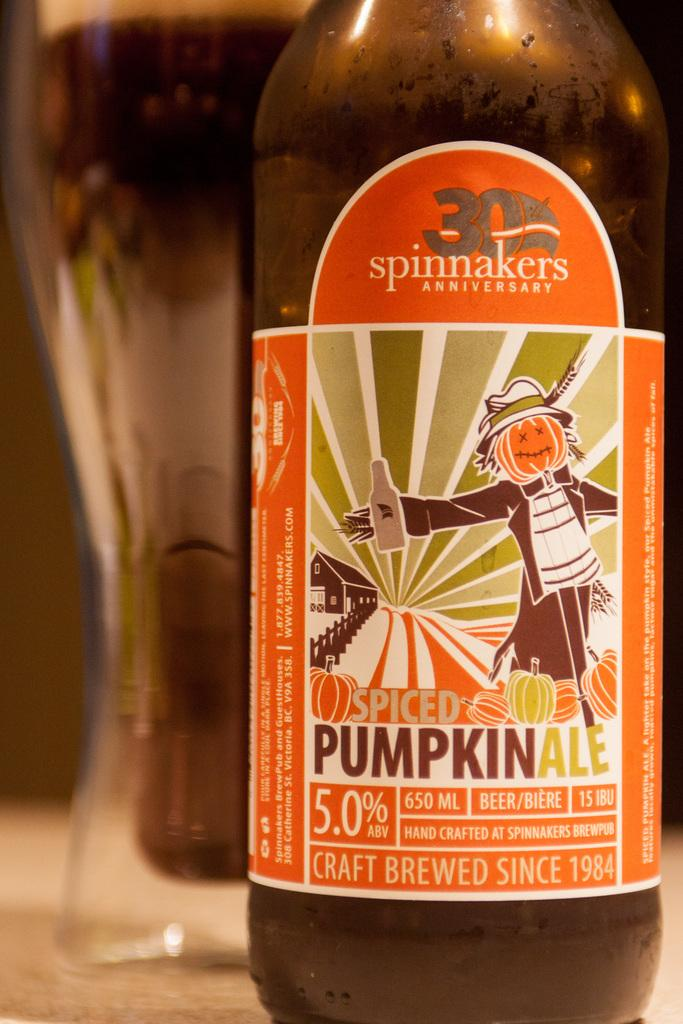<image>
Summarize the visual content of the image. A bottle of Pumpkin Spiced ale with an orange label. 